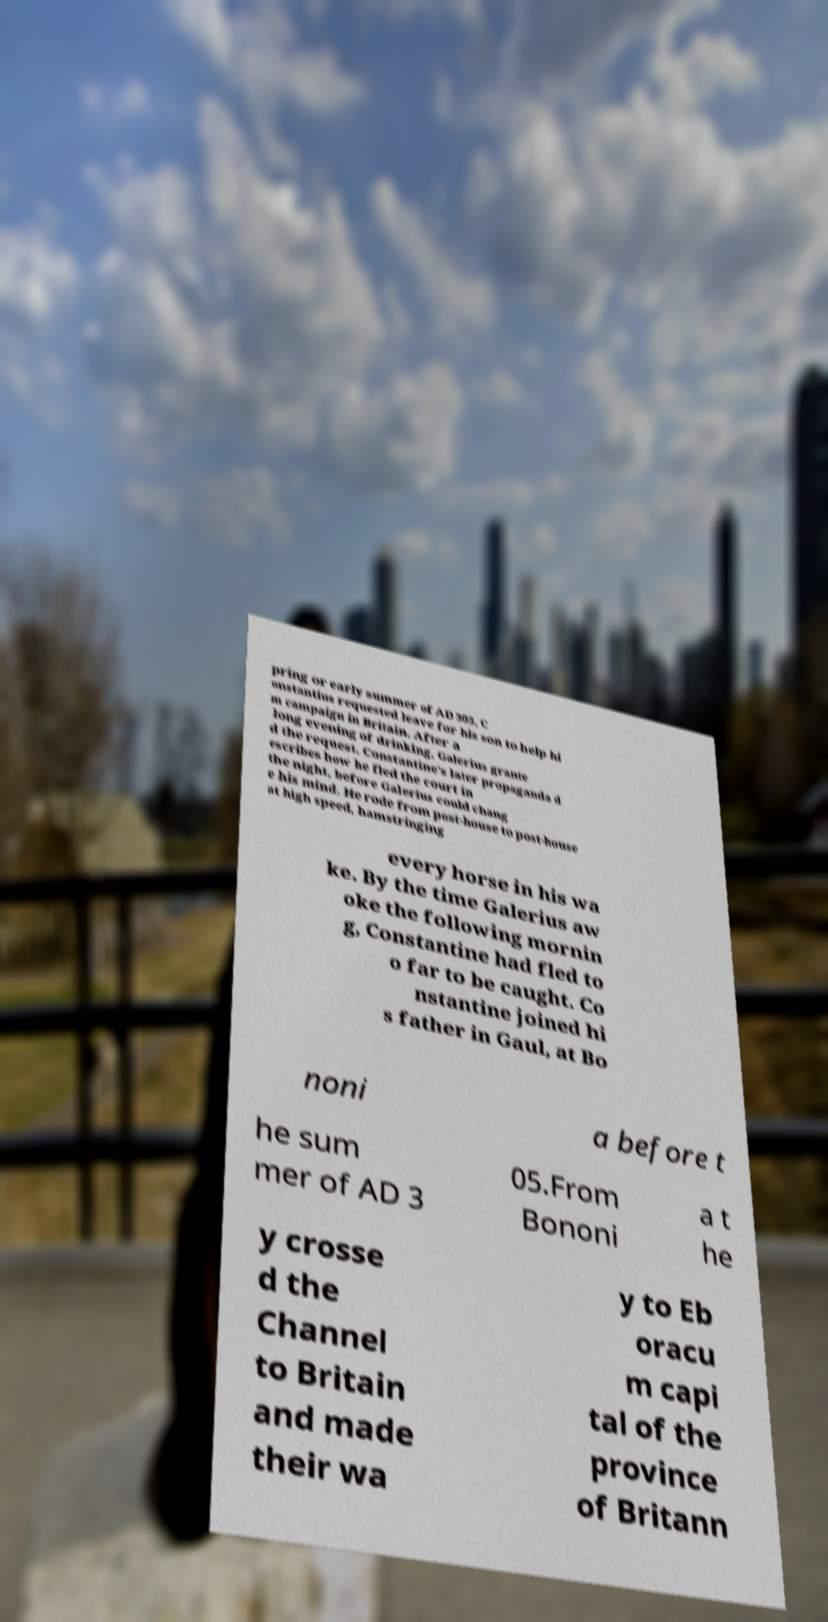Please identify and transcribe the text found in this image. pring or early summer of AD 305, C onstantius requested leave for his son to help hi m campaign in Britain. After a long evening of drinking, Galerius grante d the request. Constantine's later propaganda d escribes how he fled the court in the night, before Galerius could chang e his mind. He rode from post-house to post-house at high speed, hamstringing every horse in his wa ke. By the time Galerius aw oke the following mornin g, Constantine had fled to o far to be caught. Co nstantine joined hi s father in Gaul, at Bo noni a before t he sum mer of AD 3 05.From Bononi a t he y crosse d the Channel to Britain and made their wa y to Eb oracu m capi tal of the province of Britann 